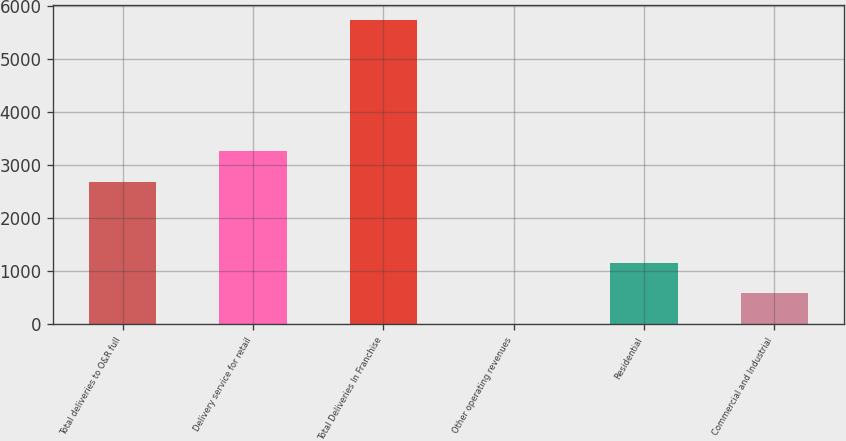Convert chart to OTSL. <chart><loc_0><loc_0><loc_500><loc_500><bar_chart><fcel>Total deliveries to O&R full<fcel>Delivery service for retail<fcel>Total Deliveries In Franchise<fcel>Other operating revenues<fcel>Residential<fcel>Commercial and Industrial<nl><fcel>2691<fcel>3263.2<fcel>5731<fcel>9<fcel>1153.4<fcel>581.2<nl></chart> 